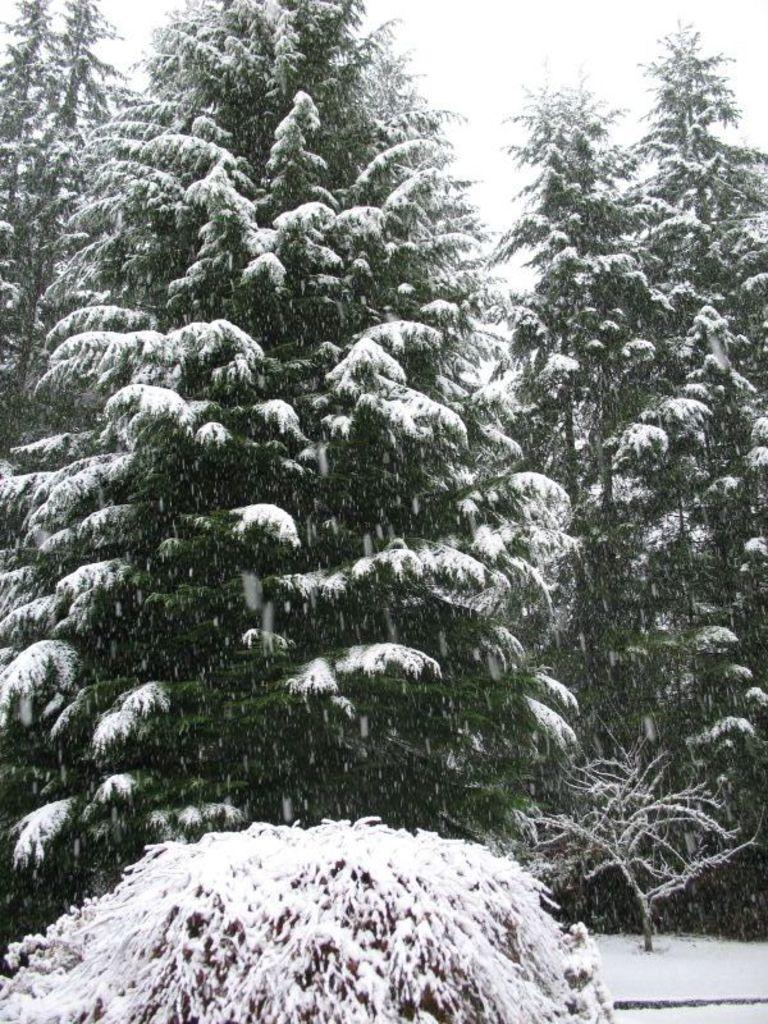What type of vegetation can be seen in the image? There are trees in the image. What is covering the trees and land in the image? There is snow on the trees and the land in the image. What can be seen in the background of the image? The sky is visible in the background of the image. What type of development can be seen in the image? There is no development or construction visible in the image; it primarily features trees, snow, and the sky. Can you see a needle in the image? There is no needle present in the image. 